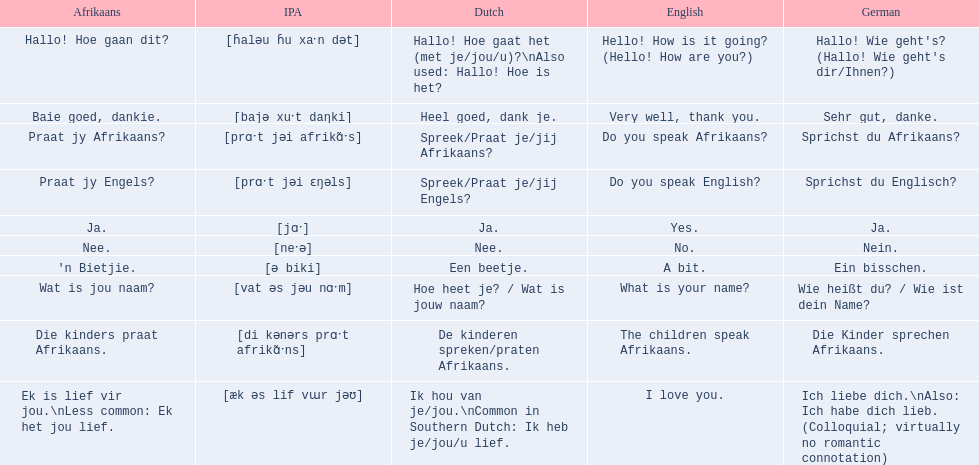Can you provide afrikaans phrases? Hallo! Hoe gaan dit?, Baie goed, dankie., Praat jy Afrikaans?, Praat jy Engels?, Ja., Nee., 'n Bietjie., Wat is jou naam?, Die kinders praat Afrikaans., Ek is lief vir jou.\nLess common: Ek het jou lief. For the phrase "die kinders praat afrikaans," what are the different translations? De kinderen spreken/praten Afrikaans., The children speak Afrikaans., Die Kinder sprechen Afrikaans. Which one is translated into german? Die Kinder sprechen Afrikaans. 